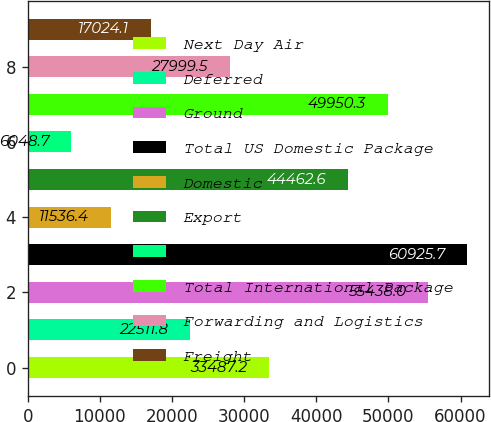<chart> <loc_0><loc_0><loc_500><loc_500><bar_chart><fcel>Next Day Air<fcel>Deferred<fcel>Ground<fcel>Total US Domestic Package<fcel>Domestic<fcel>Export<fcel>Cargo<fcel>Total International Package<fcel>Forwarding and Logistics<fcel>Freight<nl><fcel>33487.2<fcel>22511.8<fcel>55438<fcel>60925.7<fcel>11536.4<fcel>44462.6<fcel>6048.7<fcel>49950.3<fcel>27999.5<fcel>17024.1<nl></chart> 